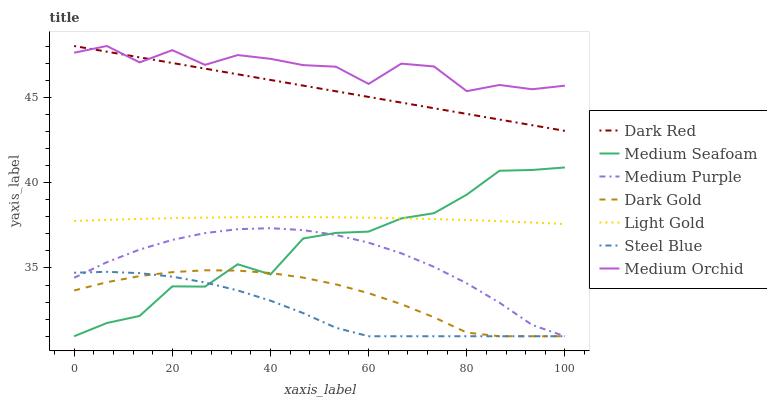Does Steel Blue have the minimum area under the curve?
Answer yes or no. Yes. Does Medium Orchid have the maximum area under the curve?
Answer yes or no. Yes. Does Dark Red have the minimum area under the curve?
Answer yes or no. No. Does Dark Red have the maximum area under the curve?
Answer yes or no. No. Is Dark Red the smoothest?
Answer yes or no. Yes. Is Medium Orchid the roughest?
Answer yes or no. Yes. Is Medium Orchid the smoothest?
Answer yes or no. No. Is Dark Red the roughest?
Answer yes or no. No. Does Dark Gold have the lowest value?
Answer yes or no. Yes. Does Dark Red have the lowest value?
Answer yes or no. No. Does Medium Orchid have the highest value?
Answer yes or no. Yes. Does Steel Blue have the highest value?
Answer yes or no. No. Is Steel Blue less than Light Gold?
Answer yes or no. Yes. Is Dark Red greater than Light Gold?
Answer yes or no. Yes. Does Medium Seafoam intersect Dark Gold?
Answer yes or no. Yes. Is Medium Seafoam less than Dark Gold?
Answer yes or no. No. Is Medium Seafoam greater than Dark Gold?
Answer yes or no. No. Does Steel Blue intersect Light Gold?
Answer yes or no. No. 